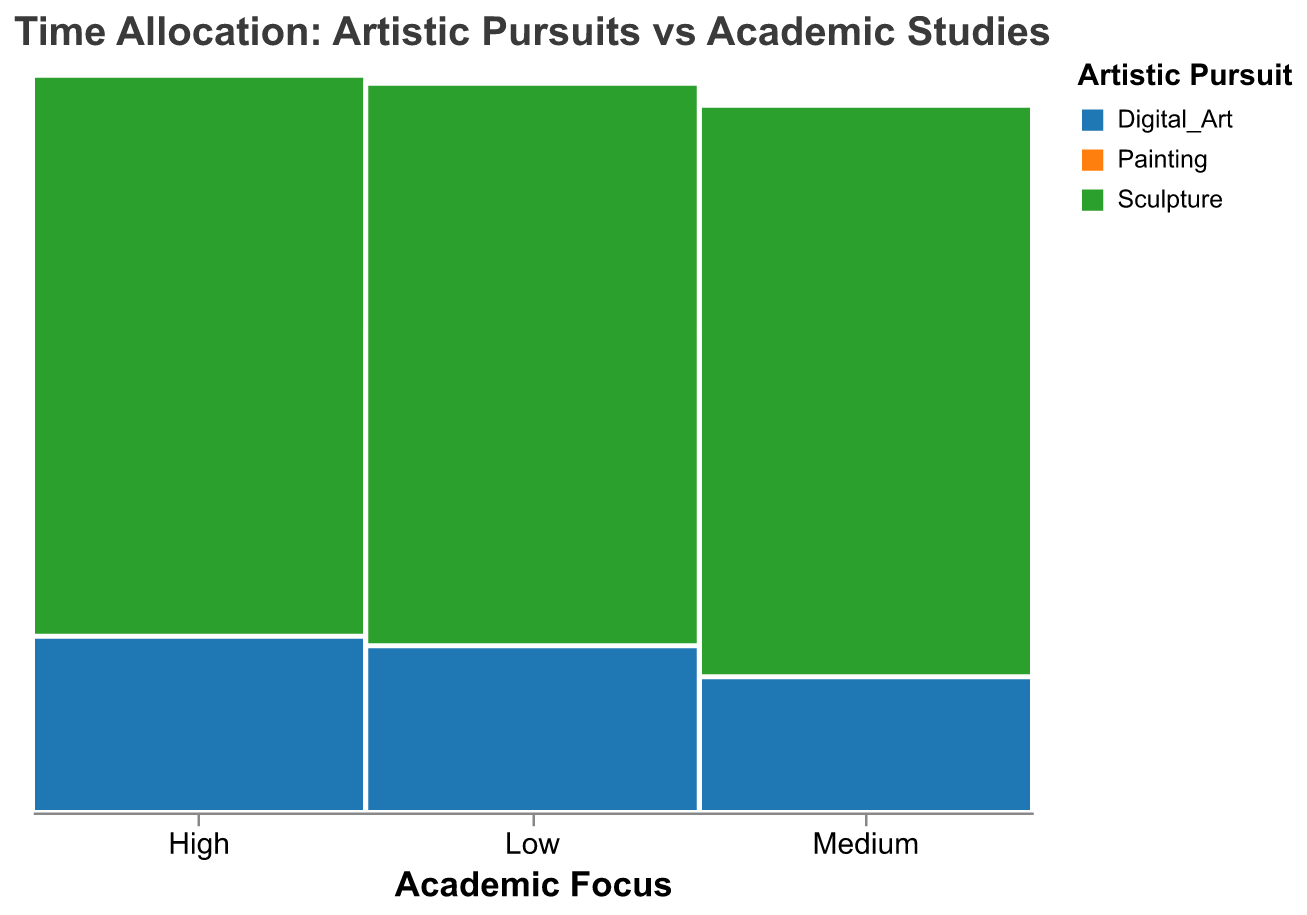What's the title of the figure? The title is usually found at the top of the figure. It gives a brief description of what the figure represents.
Answer: Time Allocation: Artistic Pursuits vs Academic Studies What are the three categories of artistic pursuits shown in the figure? The names of the artistic pursuits are displayed in the legend, usually at the side or bottom of the plot.
Answer: Painting, Sculpture, Digital Art Which academic focus category has the most students interested in Painting? To determine this, look at the Academic Focus categories (High, Medium, Low) and compare the heights of the sections allocated to Painting within each category.
Answer: Medium How many students have a high academic focus and pursue Sculpture? Hover over or look at the tooltip in the plot area where Academic Focus is "High" and Artistic Pursuit is "Sculpture" to find the number of students.
Answer: 30 Which artistic pursuit is least favored among students with a low academic focus? Look for the smallest section within the Low Academic Focus category.
Answer: Sculpture Compare the number of students who focus on Digital Art versus Sculpture within the high academic focus category. Look at the heights of the Digital Art and Sculpture sections within the High Academic Focus category and subtract the number of Sculpture students from Digital Art students: 55 (Digital Art) - 30 (Sculpture) = 25.
Answer: 25 more students focus on Digital Art than Sculpture Which combination of academic focus and artistic pursuit has the fewest number of students? To find this, identify the smallest section across all categories of Academic Focus and Artistic Pursuit.
Answer: Low Academic Focus and Sculpture How does the number of students focusing on Painting change from high to medium academic focus? Look at the heights of the Painting sections for both High and Medium categories, and then determine the difference: 80 (Medium) - 45 (High) = 35.
Answer: 35 more students focus on Painting in the Medium category than in the High category In which academic focus category is there the highest variety of artistic pursuits? This is determined by evaluating which category (High, Medium, Low) has the most evenly distributed height among the artistic pursuits (Painting, Sculpture, Digital Art).
Answer: Medium 